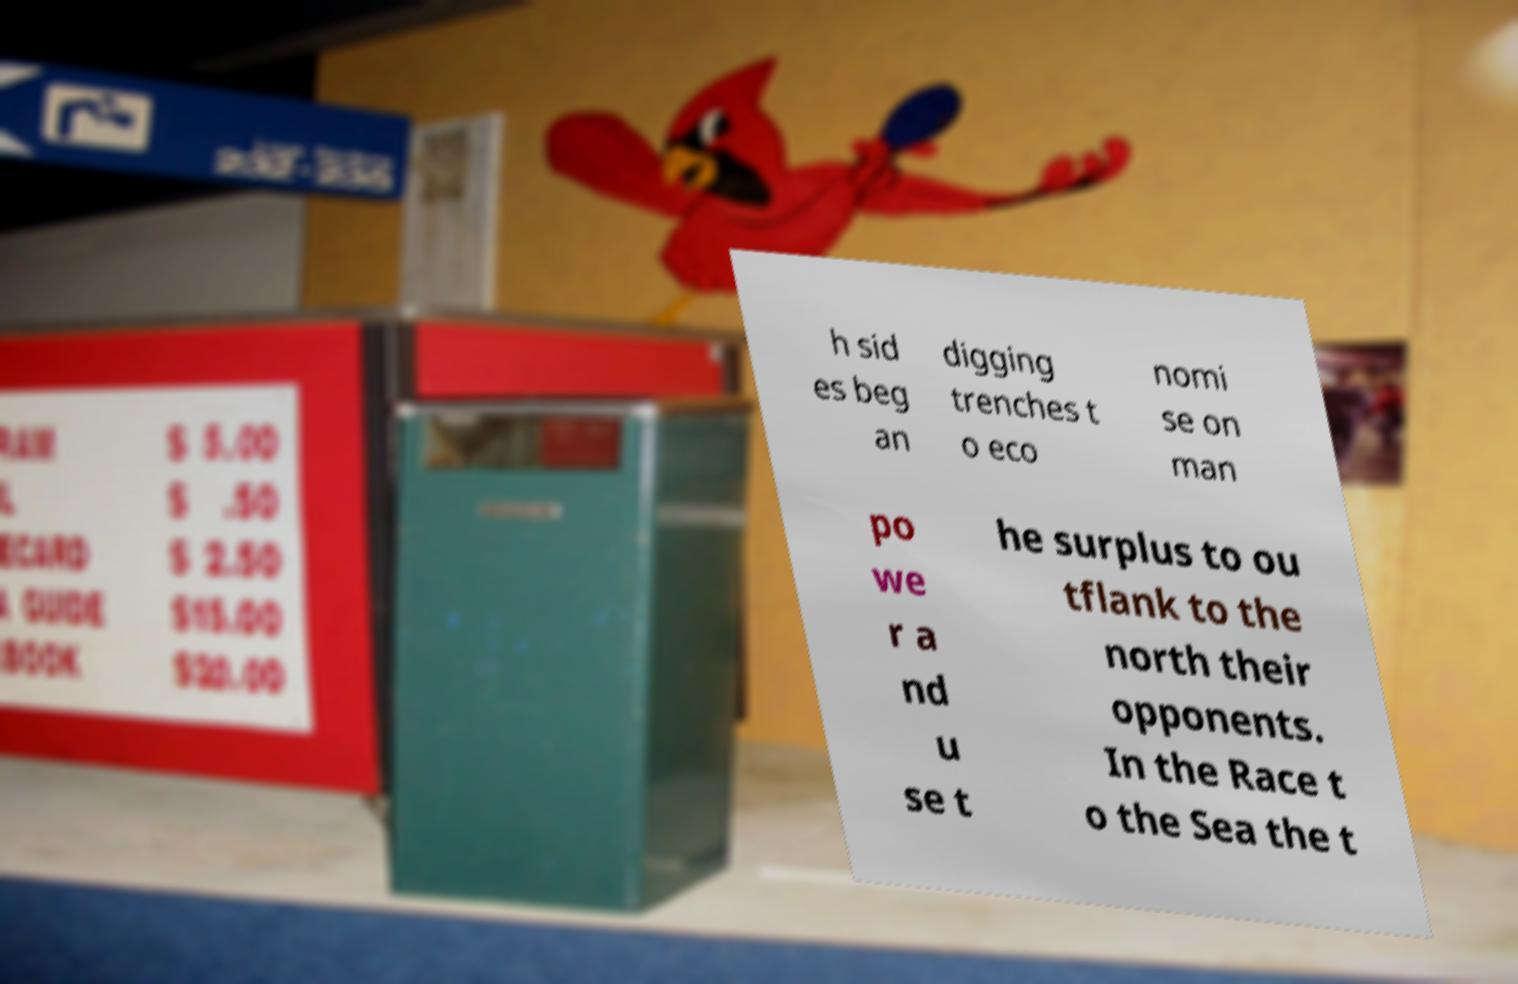Please identify and transcribe the text found in this image. h sid es beg an digging trenches t o eco nomi se on man po we r a nd u se t he surplus to ou tflank to the north their opponents. In the Race t o the Sea the t 